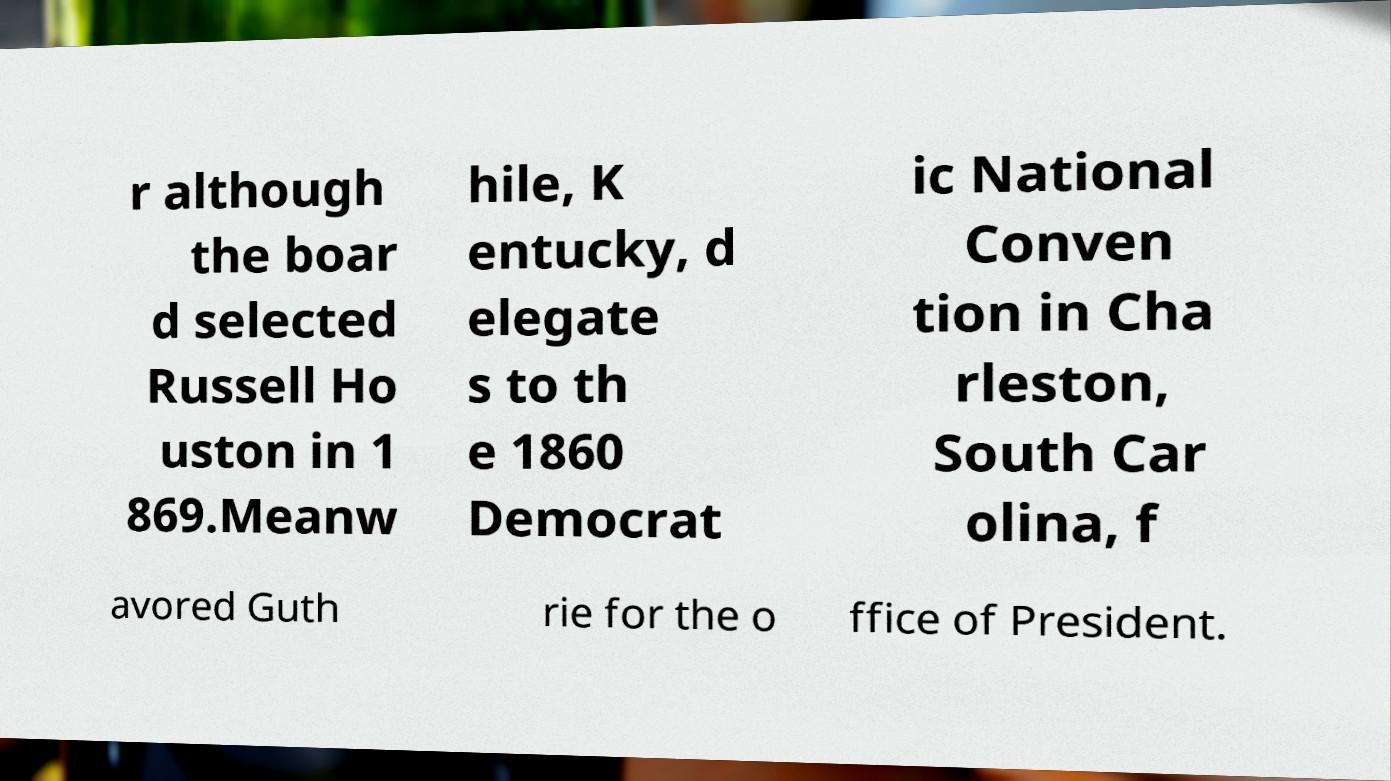What messages or text are displayed in this image? I need them in a readable, typed format. r although the boar d selected Russell Ho uston in 1 869.Meanw hile, K entucky, d elegate s to th e 1860 Democrat ic National Conven tion in Cha rleston, South Car olina, f avored Guth rie for the o ffice of President. 